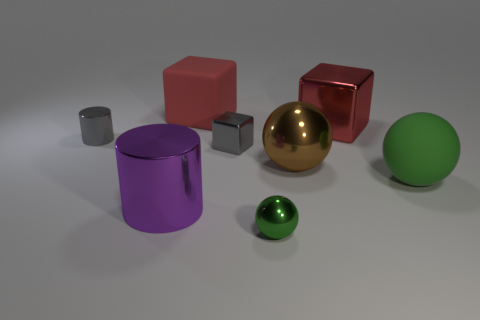How many rubber things are big balls or small cylinders?
Your response must be concise. 1. What is the large brown thing made of?
Keep it short and to the point. Metal. There is a gray block; how many cylinders are behind it?
Offer a terse response. 1. Are the big red block to the left of the big metallic block and the gray block made of the same material?
Your answer should be compact. No. How many other small green objects have the same shape as the small green object?
Your answer should be compact. 0. What number of large things are blue cylinders or brown spheres?
Keep it short and to the point. 1. Do the big rubber object that is right of the large rubber cube and the small metal cylinder have the same color?
Provide a succinct answer. No. There is a sphere that is in front of the big shiny cylinder; is it the same color as the big thing in front of the large green matte object?
Keep it short and to the point. No. Is there another sphere that has the same material as the big green ball?
Keep it short and to the point. No. How many gray things are either small metallic blocks or large metallic cylinders?
Provide a short and direct response. 1. 